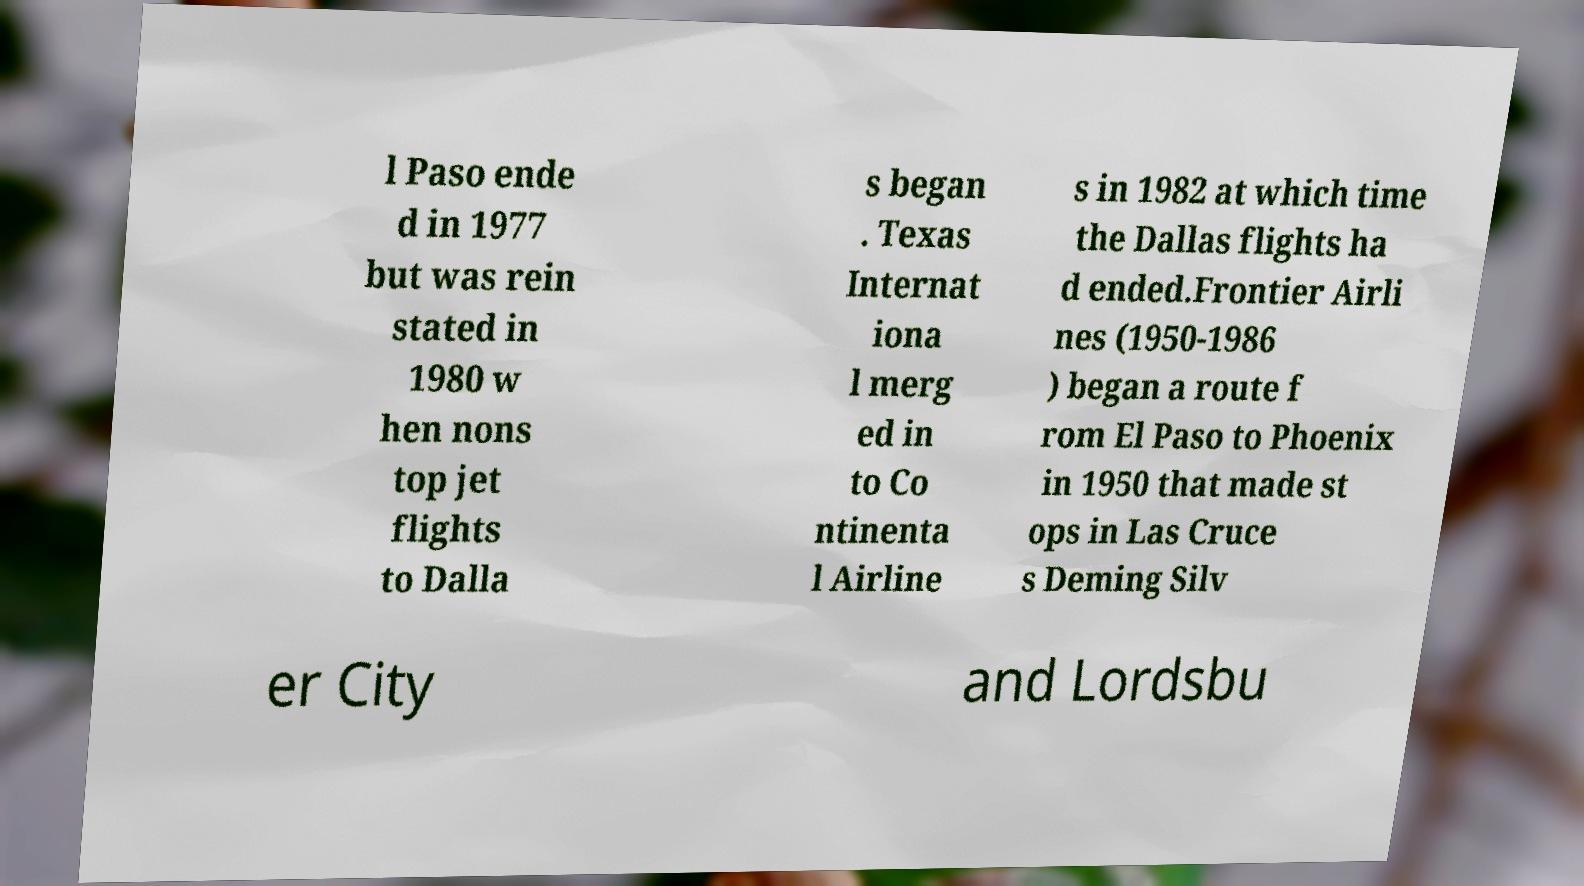For documentation purposes, I need the text within this image transcribed. Could you provide that? l Paso ende d in 1977 but was rein stated in 1980 w hen nons top jet flights to Dalla s began . Texas Internat iona l merg ed in to Co ntinenta l Airline s in 1982 at which time the Dallas flights ha d ended.Frontier Airli nes (1950-1986 ) began a route f rom El Paso to Phoenix in 1950 that made st ops in Las Cruce s Deming Silv er City and Lordsbu 